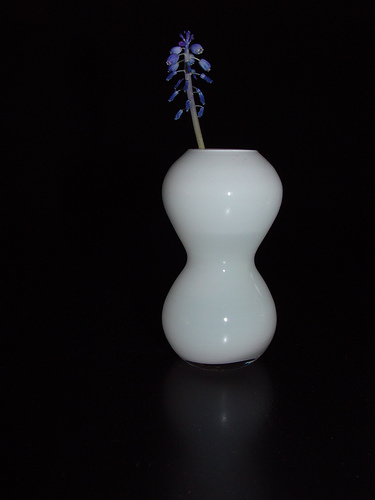<image>What pattern does the vase have? I don't know what pattern the vase has. It can be seen 'slender', 'hourglass' or 'inverted v'. Which object has a pineapple on it? There is no object with a pineapple on it in the image. What pattern does the vase have? I don't know what pattern the vase has. It seems that there is no pattern or it is not visible in the image. Which object has a pineapple on it? I am not sure which object has a pineapple on it. It is not visible in the image. 